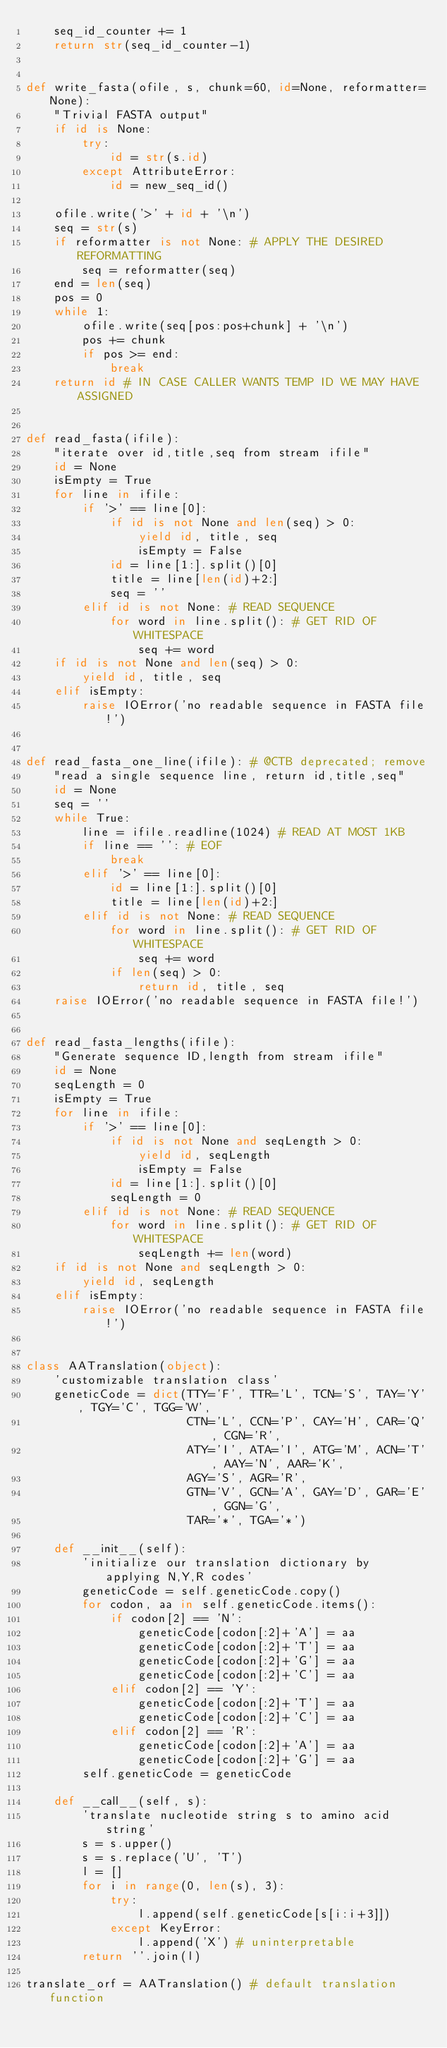<code> <loc_0><loc_0><loc_500><loc_500><_Python_>    seq_id_counter += 1
    return str(seq_id_counter-1)


def write_fasta(ofile, s, chunk=60, id=None, reformatter=None):
    "Trivial FASTA output"
    if id is None:
        try:
            id = str(s.id)
        except AttributeError:
            id = new_seq_id()

    ofile.write('>' + id + '\n')
    seq = str(s)
    if reformatter is not None: # APPLY THE DESIRED REFORMATTING
        seq = reformatter(seq)
    end = len(seq)
    pos = 0
    while 1:
        ofile.write(seq[pos:pos+chunk] + '\n')
        pos += chunk
        if pos >= end:
            break
    return id # IN CASE CALLER WANTS TEMP ID WE MAY HAVE ASSIGNED


def read_fasta(ifile):
    "iterate over id,title,seq from stream ifile"
    id = None
    isEmpty = True
    for line in ifile:
        if '>' == line[0]:
            if id is not None and len(seq) > 0:
                yield id, title, seq
                isEmpty = False
            id = line[1:].split()[0]
            title = line[len(id)+2:]
            seq = ''
        elif id is not None: # READ SEQUENCE
            for word in line.split(): # GET RID OF WHITESPACE
                seq += word
    if id is not None and len(seq) > 0:
        yield id, title, seq
    elif isEmpty:
        raise IOError('no readable sequence in FASTA file!')


def read_fasta_one_line(ifile): # @CTB deprecated; remove
    "read a single sequence line, return id,title,seq"
    id = None
    seq = ''
    while True:
        line = ifile.readline(1024) # READ AT MOST 1KB
        if line == '': # EOF
            break
        elif '>' == line[0]:
            id = line[1:].split()[0]
            title = line[len(id)+2:]
        elif id is not None: # READ SEQUENCE
            for word in line.split(): # GET RID OF WHITESPACE
                seq += word
            if len(seq) > 0:
                return id, title, seq
    raise IOError('no readable sequence in FASTA file!')


def read_fasta_lengths(ifile):
    "Generate sequence ID,length from stream ifile"
    id = None
    seqLength = 0
    isEmpty = True
    for line in ifile:
        if '>' == line[0]:
            if id is not None and seqLength > 0:
                yield id, seqLength
                isEmpty = False
            id = line[1:].split()[0]
            seqLength = 0
        elif id is not None: # READ SEQUENCE
            for word in line.split(): # GET RID OF WHITESPACE
                seqLength += len(word)
    if id is not None and seqLength > 0:
        yield id, seqLength
    elif isEmpty:
        raise IOError('no readable sequence in FASTA file!')


class AATranslation(object):
    'customizable translation class'
    geneticCode = dict(TTY='F', TTR='L', TCN='S', TAY='Y', TGY='C', TGG='W',
                       CTN='L', CCN='P', CAY='H', CAR='Q', CGN='R',
                       ATY='I', ATA='I', ATG='M', ACN='T', AAY='N', AAR='K',
                       AGY='S', AGR='R',
                       GTN='V', GCN='A', GAY='D', GAR='E', GGN='G',
                       TAR='*', TGA='*')

    def __init__(self):
        'initialize our translation dictionary by applying N,Y,R codes'
        geneticCode = self.geneticCode.copy()
        for codon, aa in self.geneticCode.items():
            if codon[2] == 'N':
                geneticCode[codon[:2]+'A'] = aa
                geneticCode[codon[:2]+'T'] = aa
                geneticCode[codon[:2]+'G'] = aa
                geneticCode[codon[:2]+'C'] = aa
            elif codon[2] == 'Y':
                geneticCode[codon[:2]+'T'] = aa
                geneticCode[codon[:2]+'C'] = aa
            elif codon[2] == 'R':
                geneticCode[codon[:2]+'A'] = aa
                geneticCode[codon[:2]+'G'] = aa
        self.geneticCode = geneticCode

    def __call__(self, s):
        'translate nucleotide string s to amino acid string'
        s = s.upper()
        s = s.replace('U', 'T')
        l = []
        for i in range(0, len(s), 3):
            try:
                l.append(self.geneticCode[s[i:i+3]])
            except KeyError:
                l.append('X') # uninterpretable
        return ''.join(l)

translate_orf = AATranslation() # default translation function
</code> 